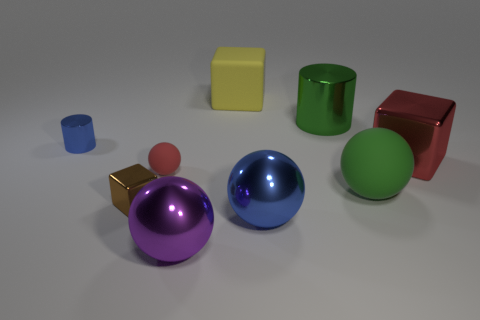Subtract all blue spheres. Subtract all gray cubes. How many spheres are left? 3 Add 1 big green balls. How many objects exist? 10 Subtract all cubes. How many objects are left? 6 Add 9 big purple metal objects. How many big purple metal objects exist? 10 Subtract 0 cyan spheres. How many objects are left? 9 Subtract all blue objects. Subtract all small objects. How many objects are left? 4 Add 4 yellow matte objects. How many yellow matte objects are left? 5 